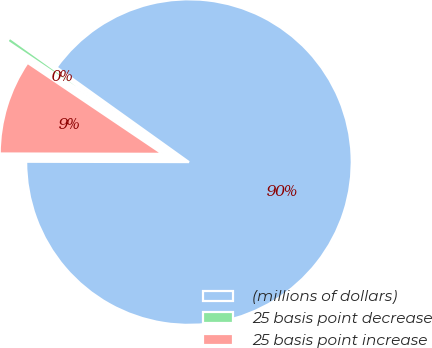Convert chart. <chart><loc_0><loc_0><loc_500><loc_500><pie_chart><fcel>(millions of dollars)<fcel>25 basis point decrease<fcel>25 basis point increase<nl><fcel>90.14%<fcel>0.44%<fcel>9.41%<nl></chart> 